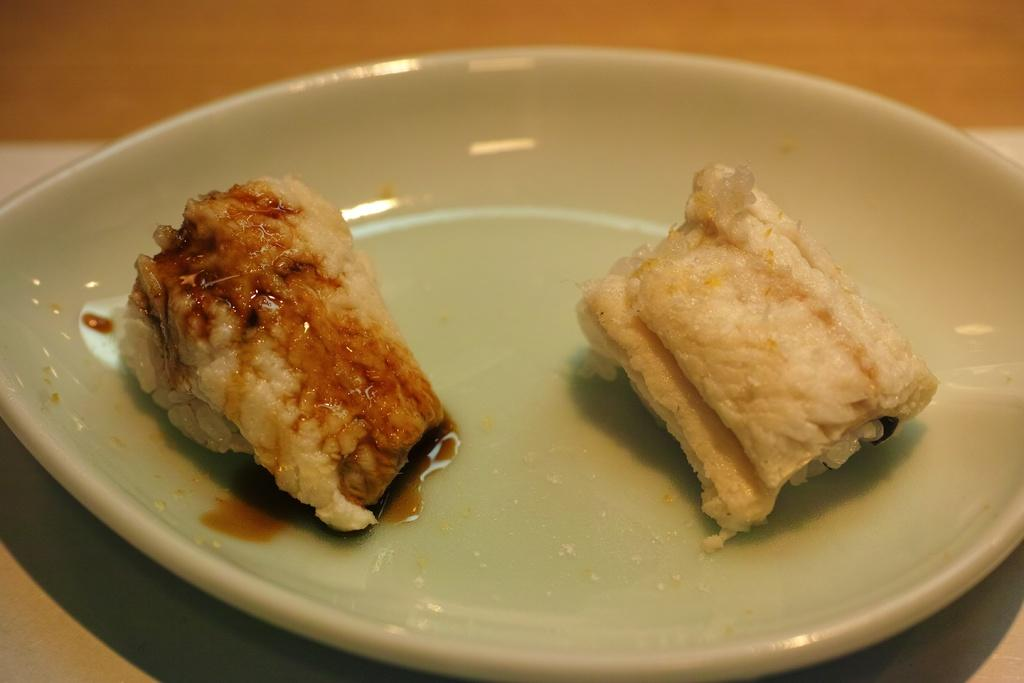What is on the plate that is visible in the image? There is food on a plate in the image. What type of furniture is present in the image? There is a table in the image. How does the food on the plate express its feelings of hate in the image? The food on the plate does not express any feelings, as it is an inanimate object. 